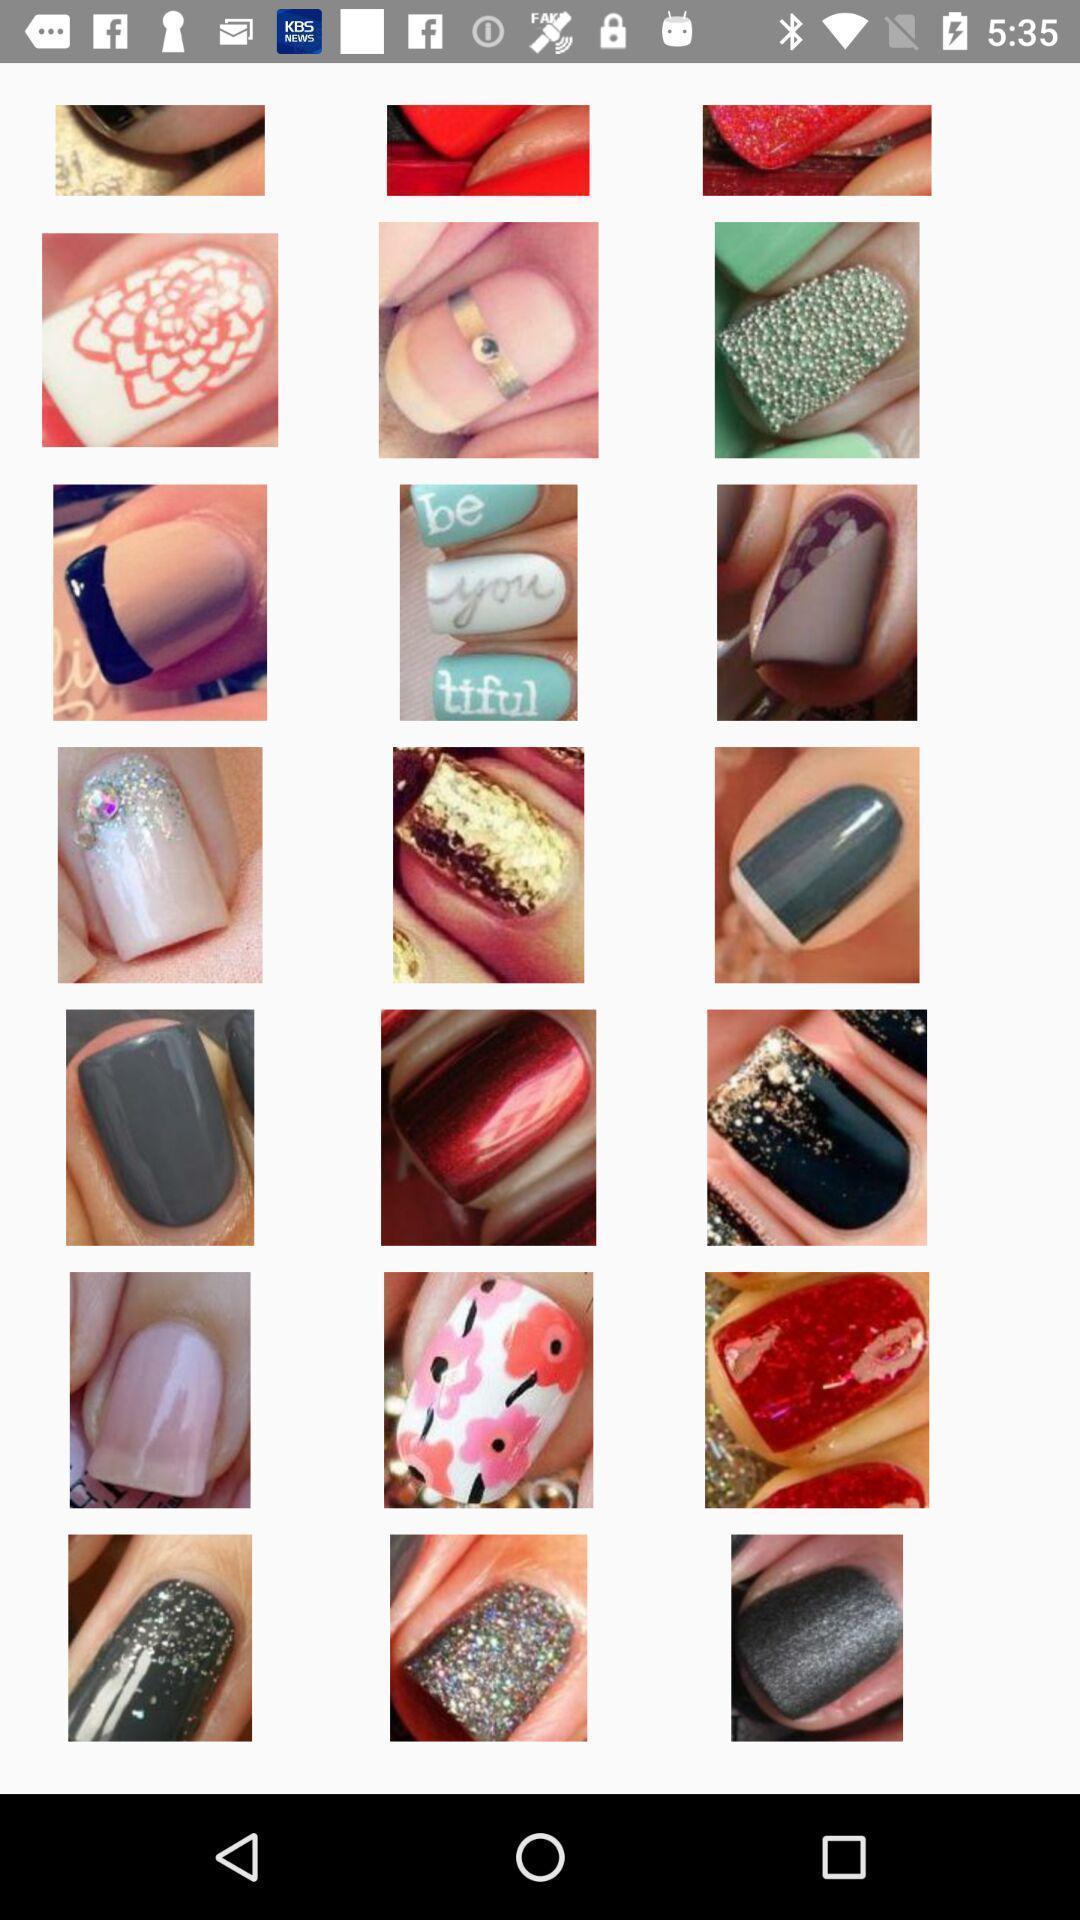What is the overall content of this screenshot? Screen page displaying various designed nails. 